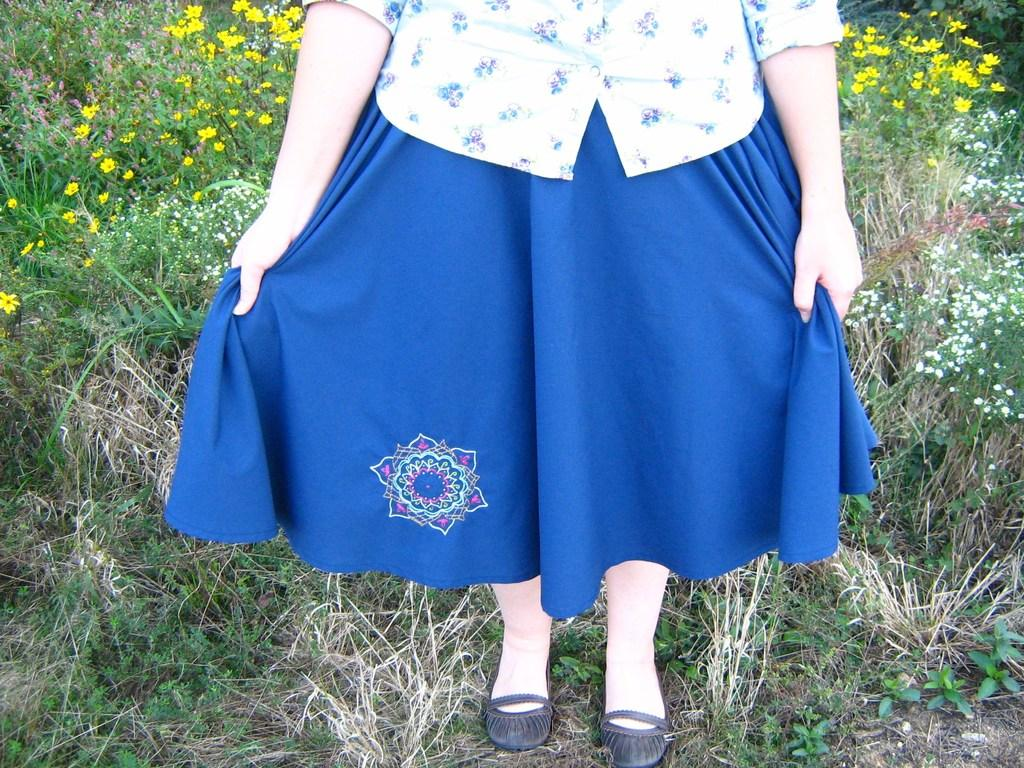What is the main subject of the image? There is a person standing in the image. Where is the person standing? The person is standing on the grass. What is the grass located on? The grass is on the ground. What can be seen in the background of the image? There are plants with flowers in the background of the image. How many brothers does the person in the image have? There is no information about the person's brothers in the image. What type of bird can be seen flying in the image? There is no bird visible in the image. 